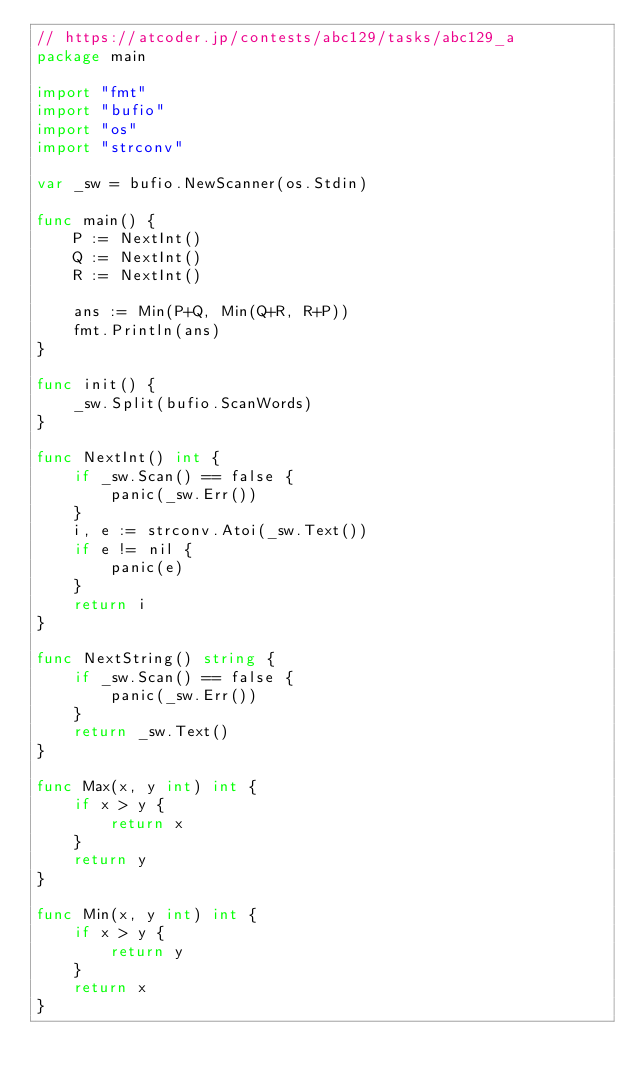<code> <loc_0><loc_0><loc_500><loc_500><_Go_>// https://atcoder.jp/contests/abc129/tasks/abc129_a
package main

import "fmt"
import "bufio"
import "os"
import "strconv"

var _sw = bufio.NewScanner(os.Stdin)

func main() {
	P := NextInt()
	Q := NextInt()
	R := NextInt()

	ans := Min(P+Q, Min(Q+R, R+P))
	fmt.Println(ans)
}

func init() {
	_sw.Split(bufio.ScanWords)
}

func NextInt() int {
	if _sw.Scan() == false {
		panic(_sw.Err())
	}
	i, e := strconv.Atoi(_sw.Text())
	if e != nil {
		panic(e)
	}
	return i
}

func NextString() string {
	if _sw.Scan() == false {
		panic(_sw.Err())
	}
	return _sw.Text()
}

func Max(x, y int) int {
	if x > y {
		return x
	}
	return y
}

func Min(x, y int) int {
	if x > y {
		return y
	}
	return x
}
</code> 